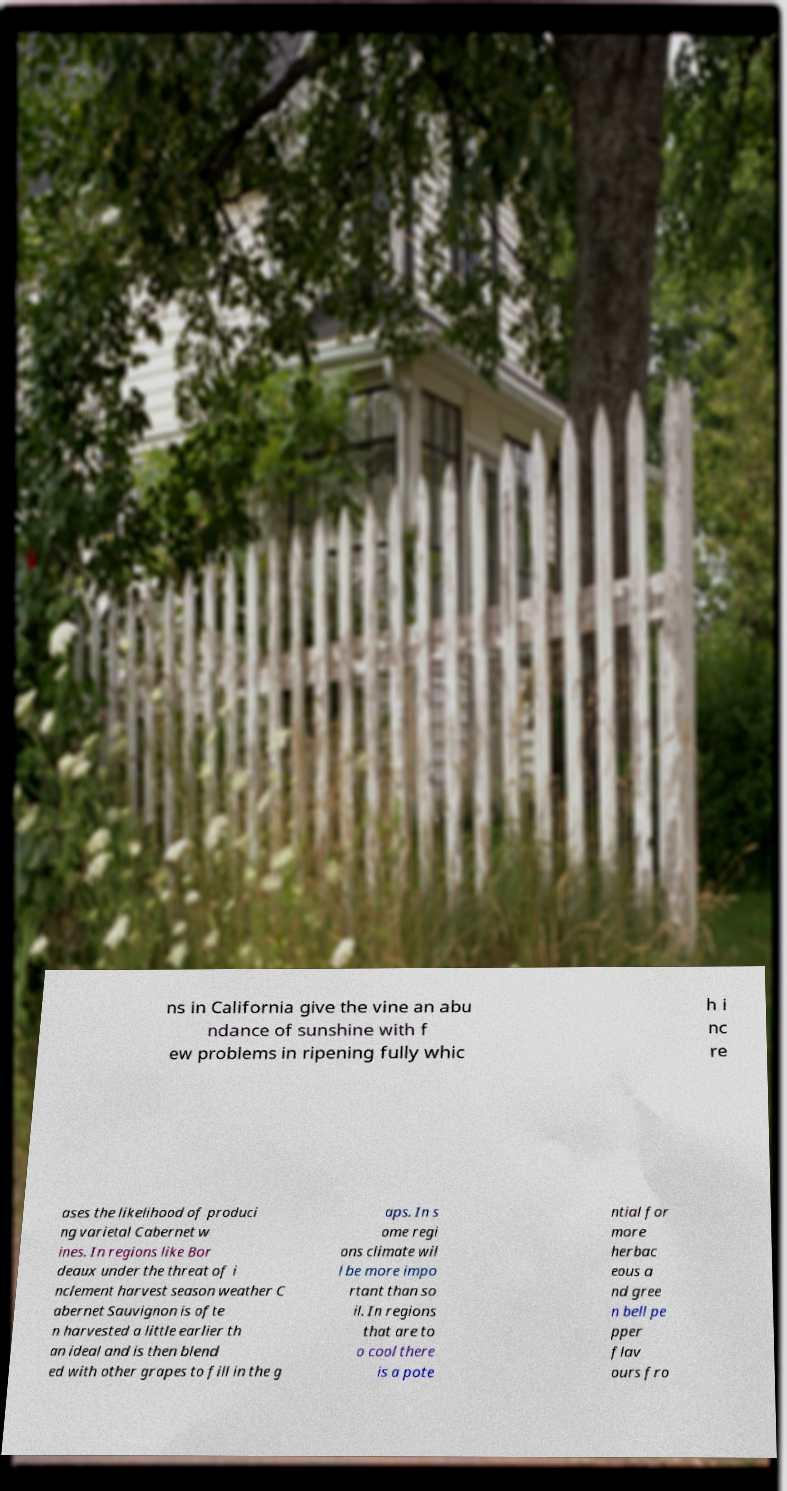There's text embedded in this image that I need extracted. Can you transcribe it verbatim? ns in California give the vine an abu ndance of sunshine with f ew problems in ripening fully whic h i nc re ases the likelihood of produci ng varietal Cabernet w ines. In regions like Bor deaux under the threat of i nclement harvest season weather C abernet Sauvignon is ofte n harvested a little earlier th an ideal and is then blend ed with other grapes to fill in the g aps. In s ome regi ons climate wil l be more impo rtant than so il. In regions that are to o cool there is a pote ntial for more herbac eous a nd gree n bell pe pper flav ours fro 